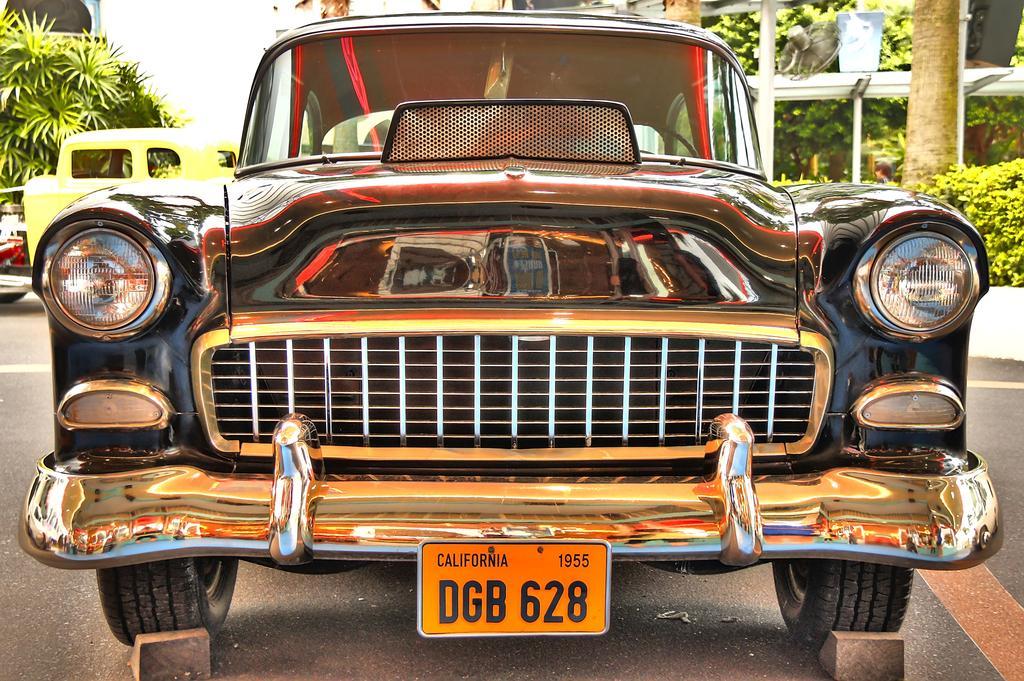Could you give a brief overview of what you see in this image? In front of the picture, we see the black color car parked on the road. At the bottom, we see the road and the stones. We see a number plate in orange color. On the right side, we see the shrubs, the stem of the tree, pole and a fan. There are trees in the background. On the left side, we see the trees and a vehicle in yellow color. In the background, we see the sky. 